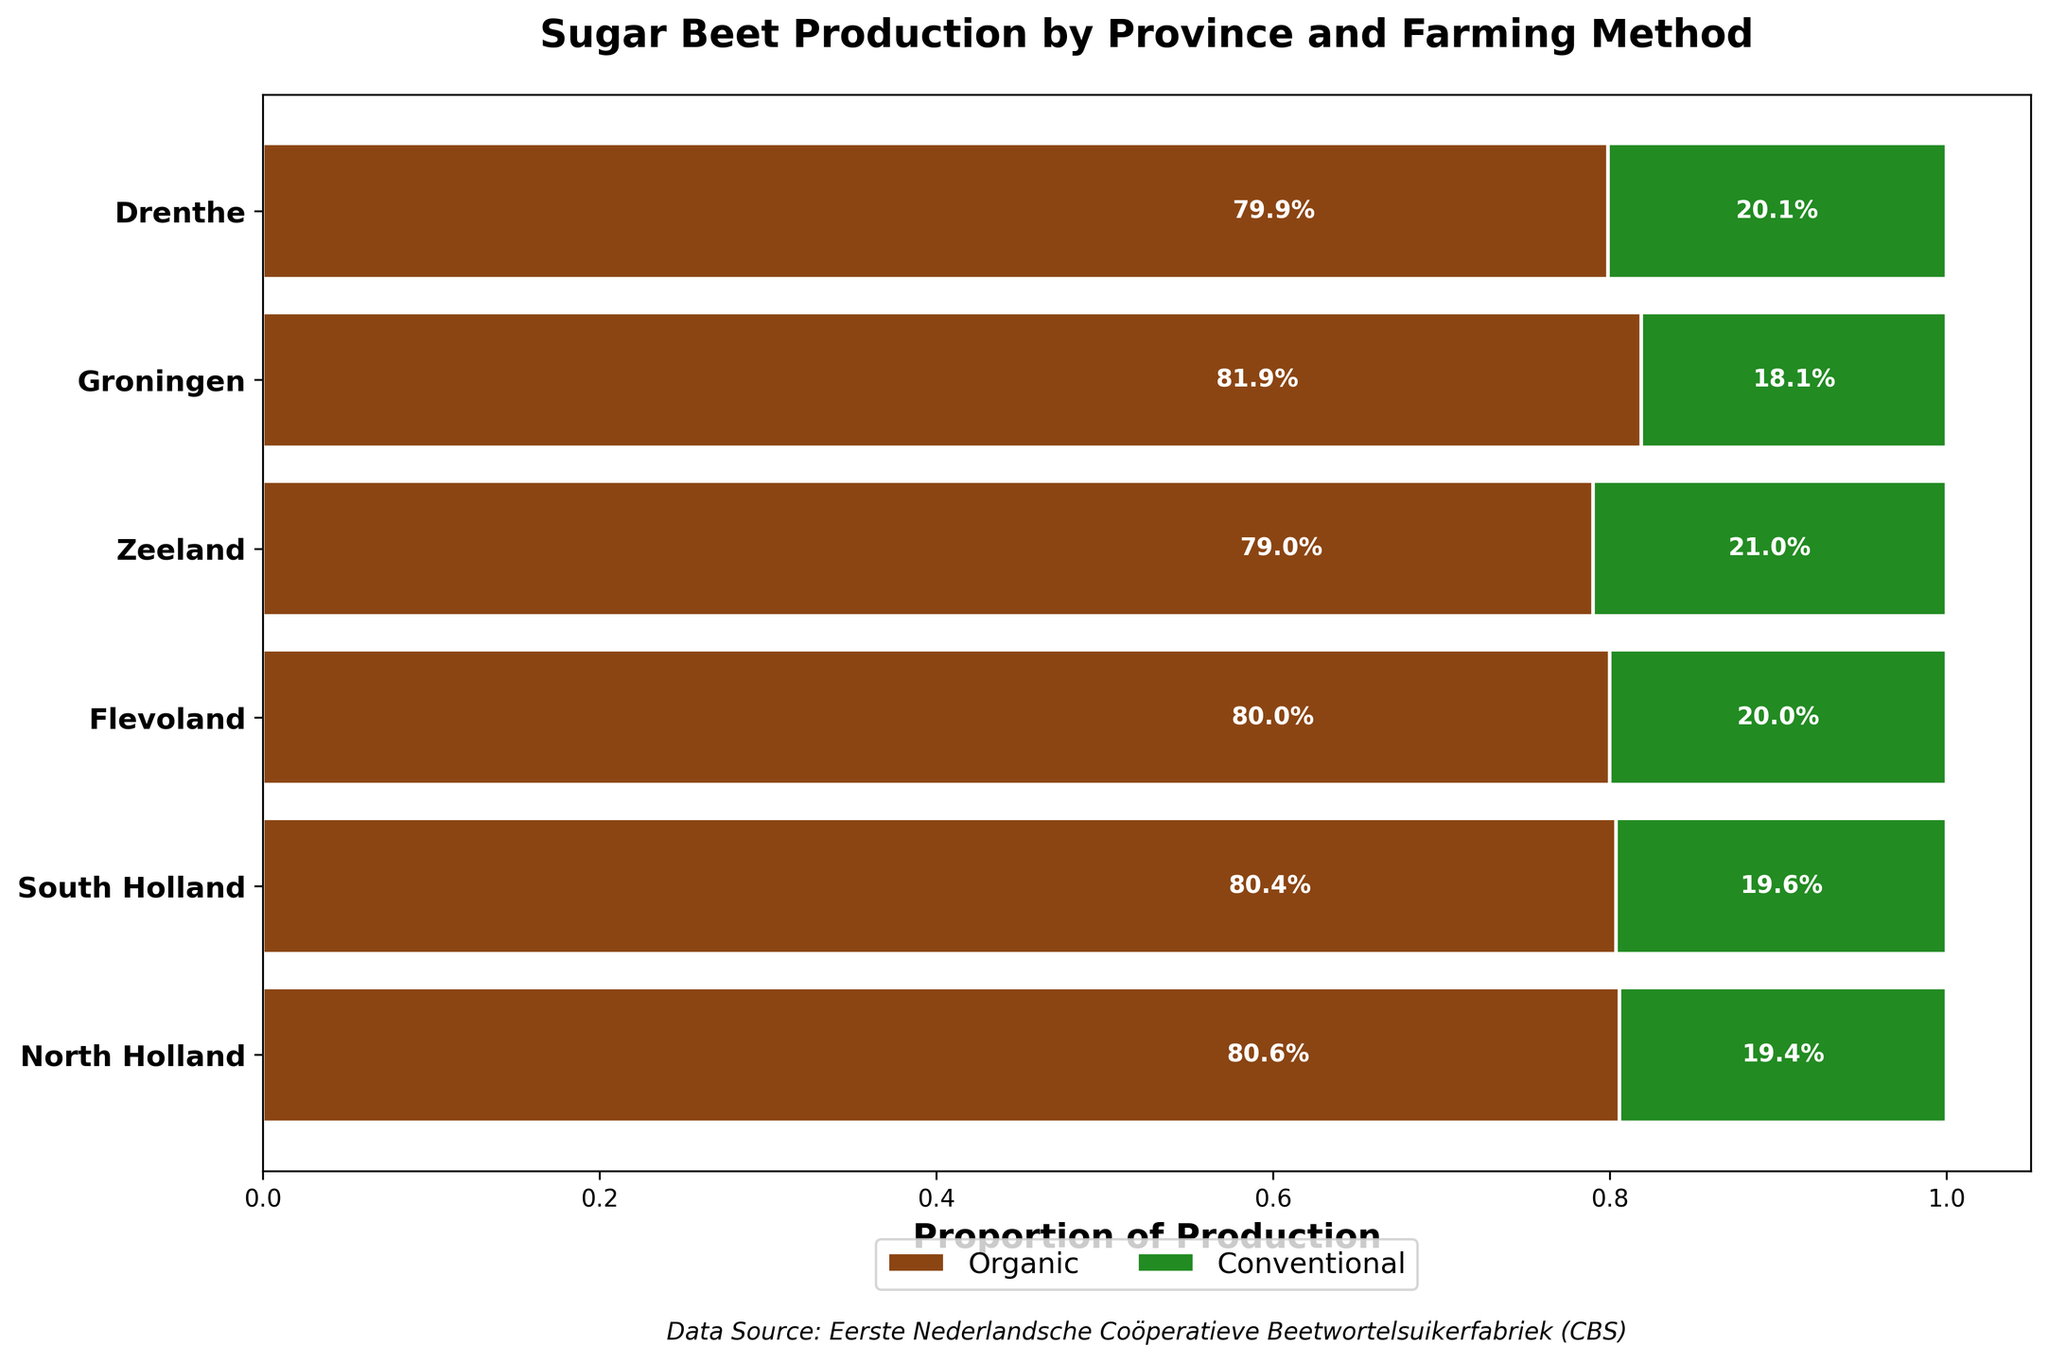What is the title of the mosaic plot? The title of the mosaic plot is displayed at the top and reads "Sugar Beet Production by Province and Farming Method".
Answer: Sugar Beet Production by Province and Farming Method How many provinces are represented in the mosaic plot? The number of horizontal bars in the plot corresponds to the distinct provinces represented. By counting these bars, we see there are six provinces.
Answer: Six What color represents the Organic farming method in the mosaic plot? The plot uses colors to differentiate between farming methods. The Organic method is represented by the green color.
Answer: Green Which province has the smallest proportion of Organic production? To find the smallest proportion of Organic production, we compare the green segments across all provinces' horizontal bars. The province with the narrowest green segment is South Holland.
Answer: South Holland What percentage of sugar beet production in Drenthe is Organic? Look at the green section of Drenthe's bar and find the percentage inside it, which is approximately 19.4%.
Answer: 19.4% Which province has the highest difference in sugar beet production between Conventional and Organic methods? Compare the length differences of green (Organic) and brown (Conventional) sections across all provinces. The max difference is observed in Flevoland.
Answer: Flevoland How does the proportion of Conventional production in Zeeland compare to North Holland? Check the width of the brown sections in both Zeeland and North Holland. Zeeland's brown section is narrower than North Holland's, indicating Zeeland has a smaller proportion.
Answer: Smaller What farming method dominates sugar beet production in Flevoland? Look at the widths of green and brown segments in Flevoland. The brown segment is considerably wider, indicating the Conventional method dominates.
Answer: Conventional What is the sum of the Organic production percentages in Drenthe and Groningen? Look at the green sections in Drenthe and Groningen, which are around 19.4% and 20.0%, respectively. Adding these gives 39.4%.
Answer: 39.4% How is the proportion of sugar beet production in South Holland divided between the two farming methods? Check the section proportions for South Holland. Organic is approximately 18.1%, and Conventional is approximately 81.9%.
Answer: Organic: 18.1%, Conventional: 81.9% 